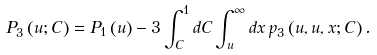<formula> <loc_0><loc_0><loc_500><loc_500>P _ { 3 } \left ( u ; C \right ) = P _ { 1 } \left ( u \right ) - 3 \int _ { C } ^ { 1 } d C \int _ { u } ^ { \infty } d x \, p _ { 3 } \left ( u , u , x ; C \right ) .</formula> 